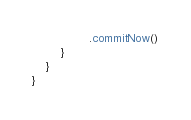<code> <loc_0><loc_0><loc_500><loc_500><_Kotlin_>                .commitNow()
        }
    }
}</code> 